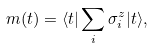<formula> <loc_0><loc_0><loc_500><loc_500>m ( t ) = \langle t | \sum _ { i } \sigma _ { i } ^ { z } | t \rangle ,</formula> 